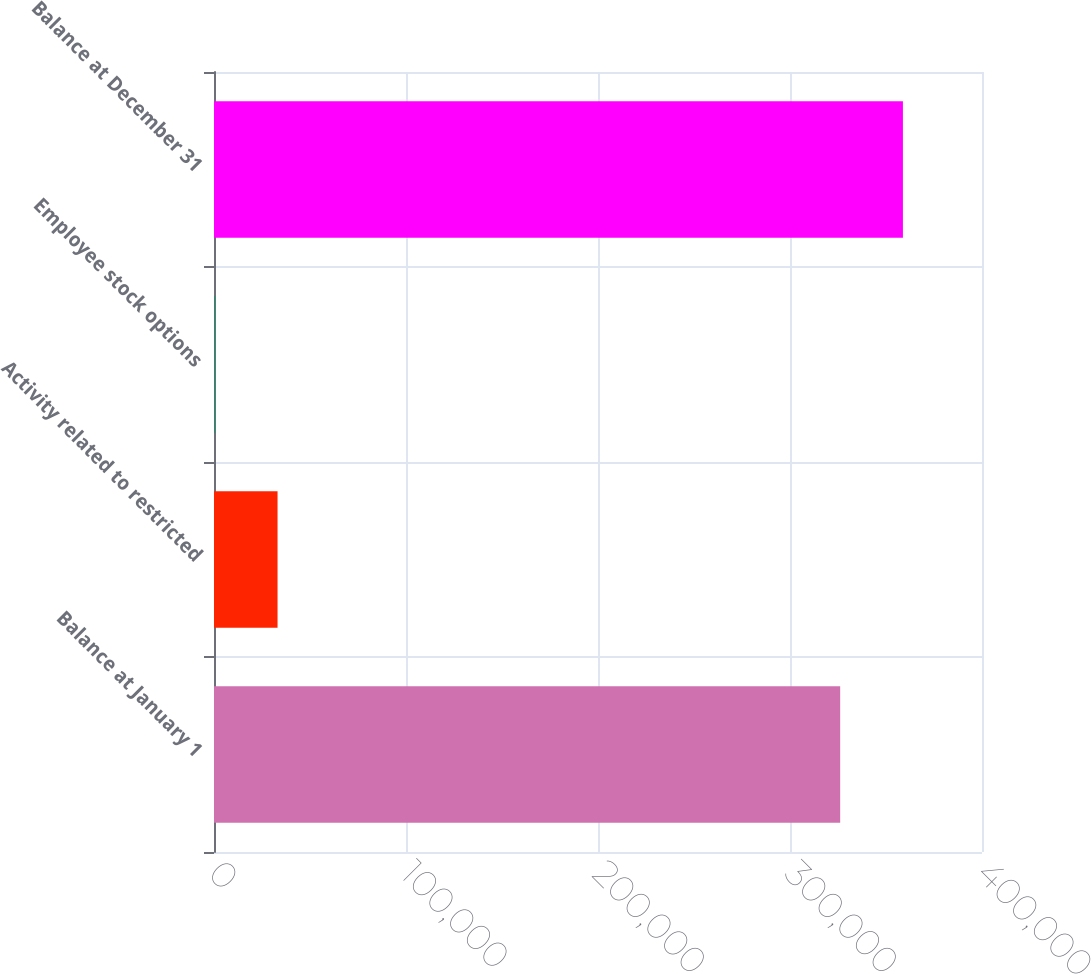Convert chart. <chart><loc_0><loc_0><loc_500><loc_500><bar_chart><fcel>Balance at January 1<fcel>Activity related to restricted<fcel>Employee stock options<fcel>Balance at December 31<nl><fcel>326133<fcel>33097.3<fcel>416<fcel>358814<nl></chart> 